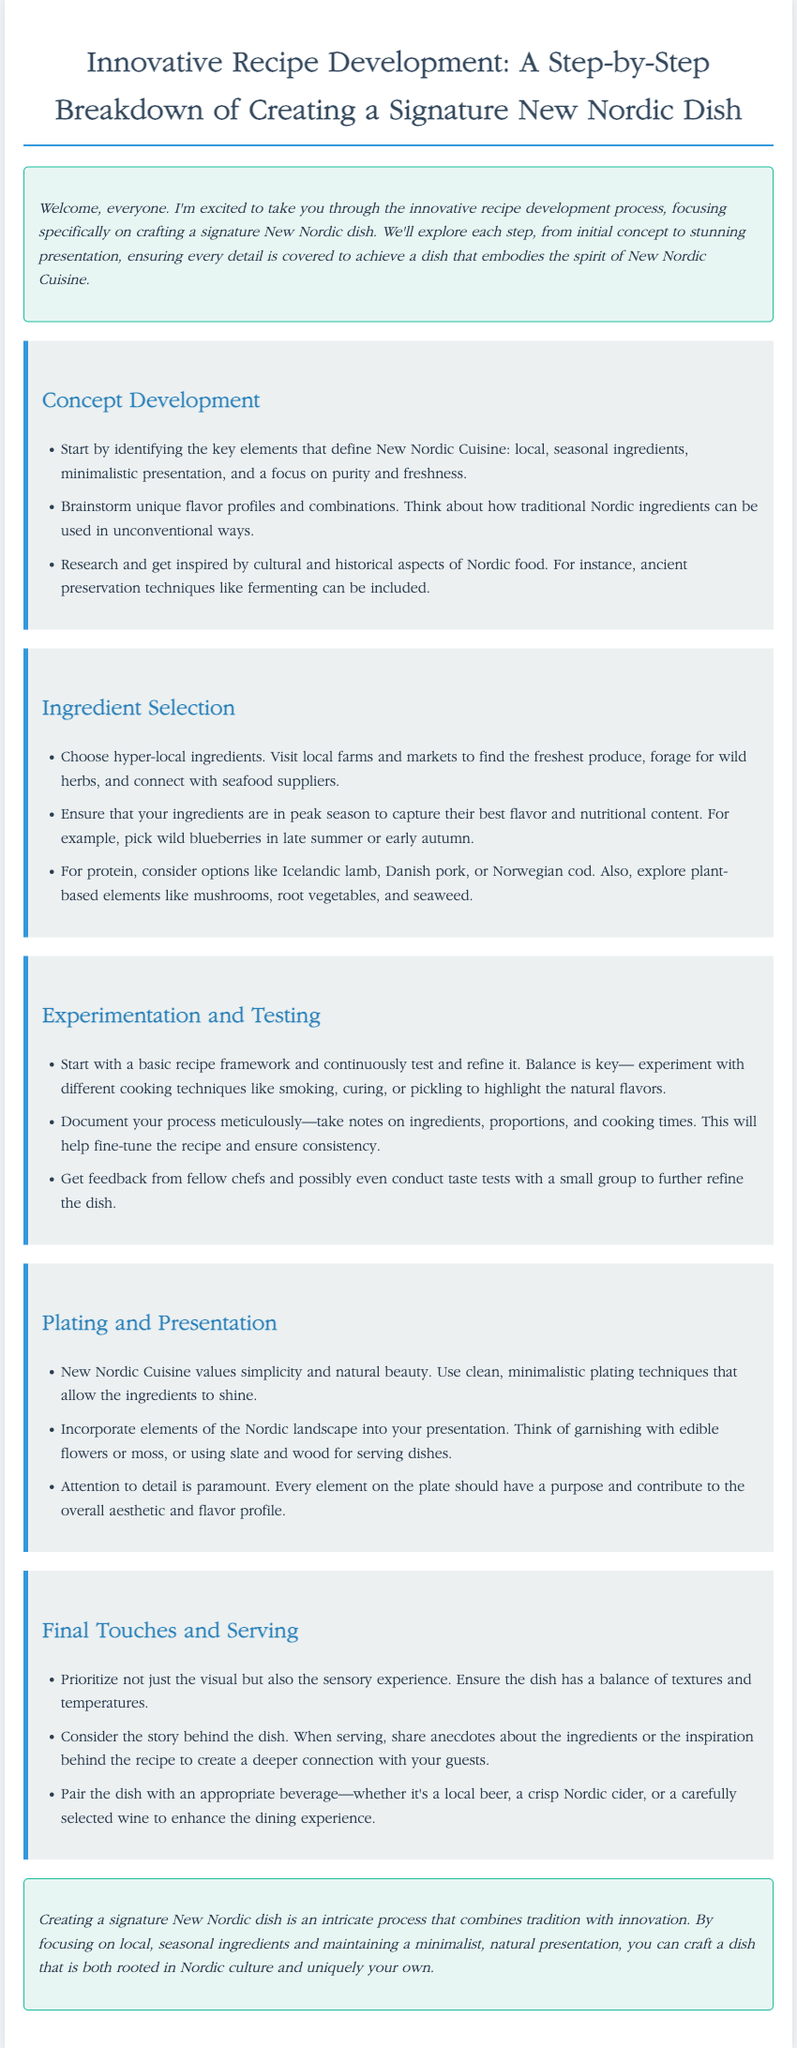What is the title of the document? The title is specified in the document's header as the main focus of the content.
Answer: Innovative Recipe Development: A Step-by-Step Breakdown of Creating a Signature New Nordic Dish What is emphasized in New Nordic Cuisine? The key elements that define this cuisine are detailed in the concept development section.
Answer: Local, seasonal ingredients What protein options are suggested? The ingredient selection section lists various protein sources that can be utilized in New Nordic dishes.
Answer: Icelandic lamb What cooking techniques should be experimented with? The experimentation and testing section suggests various methods that enhance flavor profiles.
Answer: Smoking, curing, or pickling What is a recommended plating style for New Nordic dishes? The plating and presentation section addresses the preferred aesthetic for serving these dishes.
Answer: Minimalistic plating techniques What should be prioritized in the final touches? This aspect is covered in the final touches and serving section, highlighting the importance of overall dish experience.
Answer: Visual and sensory experience What type of stories should be shared when serving? The final touches and serving section recommends incorporating narratives that deepen guests' connections with the dish.
Answer: Anecdotes about the ingredients What is the main focus of the conclusion? The conclusion summarizes the essential philosophy behind creating a New Nordic dish.
Answer: Tradition with innovation 